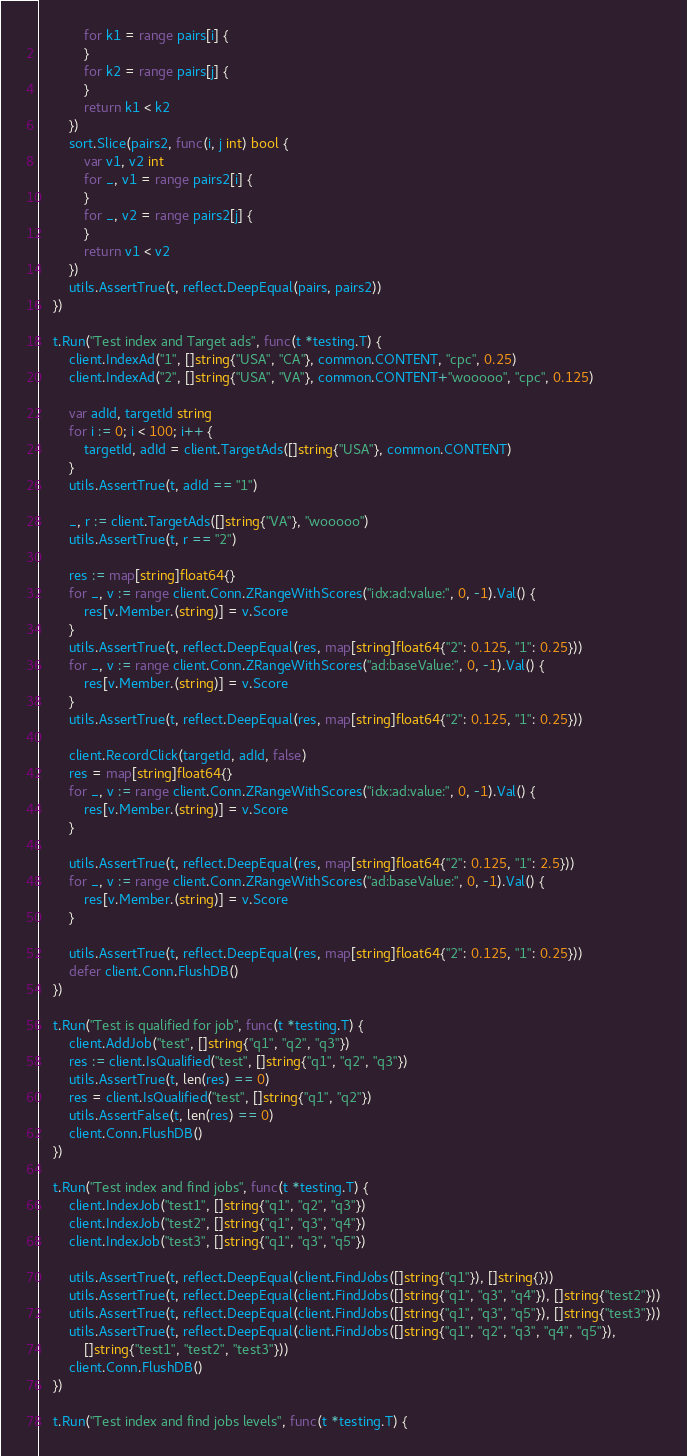Convert code to text. <code><loc_0><loc_0><loc_500><loc_500><_Go_>			for k1 = range pairs[i] {
			}
			for k2 = range pairs[j] {
			}
			return k1 < k2
		})
		sort.Slice(pairs2, func(i, j int) bool {
			var v1, v2 int
			for _, v1 = range pairs2[i] {
			}
			for _, v2 = range pairs2[j] {
			}
			return v1 < v2
		})
		utils.AssertTrue(t, reflect.DeepEqual(pairs, pairs2))
	})

	t.Run("Test index and Target ads", func(t *testing.T) {
		client.IndexAd("1", []string{"USA", "CA"}, common.CONTENT, "cpc", 0.25)
		client.IndexAd("2", []string{"USA", "VA"}, common.CONTENT+"wooooo", "cpc", 0.125)

		var adId, targetId string
		for i := 0; i < 100; i++ {
			targetId, adId = client.TargetAds([]string{"USA"}, common.CONTENT)
		}
		utils.AssertTrue(t, adId == "1")

		_, r := client.TargetAds([]string{"VA"}, "wooooo")
		utils.AssertTrue(t, r == "2")

		res := map[string]float64{}
		for _, v := range client.Conn.ZRangeWithScores("idx:ad:value:", 0, -1).Val() {
			res[v.Member.(string)] = v.Score
		}
		utils.AssertTrue(t, reflect.DeepEqual(res, map[string]float64{"2": 0.125, "1": 0.25}))
		for _, v := range client.Conn.ZRangeWithScores("ad:baseValue:", 0, -1).Val() {
			res[v.Member.(string)] = v.Score
		}
		utils.AssertTrue(t, reflect.DeepEqual(res, map[string]float64{"2": 0.125, "1": 0.25}))

		client.RecordClick(targetId, adId, false)
		res = map[string]float64{}
		for _, v := range client.Conn.ZRangeWithScores("idx:ad:value:", 0, -1).Val() {
			res[v.Member.(string)] = v.Score
		}

		utils.AssertTrue(t, reflect.DeepEqual(res, map[string]float64{"2": 0.125, "1": 2.5}))
		for _, v := range client.Conn.ZRangeWithScores("ad:baseValue:", 0, -1).Val() {
			res[v.Member.(string)] = v.Score
		}

		utils.AssertTrue(t, reflect.DeepEqual(res, map[string]float64{"2": 0.125, "1": 0.25}))
		defer client.Conn.FlushDB()
	})

	t.Run("Test is qualified for job", func(t *testing.T) {
		client.AddJob("test", []string{"q1", "q2", "q3"})
		res := client.IsQualified("test", []string{"q1", "q2", "q3"})
		utils.AssertTrue(t, len(res) == 0)
		res = client.IsQualified("test", []string{"q1", "q2"})
		utils.AssertFalse(t, len(res) == 0)
		client.Conn.FlushDB()
	})

	t.Run("Test index and find jobs", func(t *testing.T) {
		client.IndexJob("test1", []string{"q1", "q2", "q3"})
		client.IndexJob("test2", []string{"q1", "q3", "q4"})
		client.IndexJob("test3", []string{"q1", "q3", "q5"})

		utils.AssertTrue(t, reflect.DeepEqual(client.FindJobs([]string{"q1"}), []string{}))
		utils.AssertTrue(t, reflect.DeepEqual(client.FindJobs([]string{"q1", "q3", "q4"}), []string{"test2"}))
		utils.AssertTrue(t, reflect.DeepEqual(client.FindJobs([]string{"q1", "q3", "q5"}), []string{"test3"}))
		utils.AssertTrue(t, reflect.DeepEqual(client.FindJobs([]string{"q1", "q2", "q3", "q4", "q5"}),
			[]string{"test1", "test2", "test3"}))
		client.Conn.FlushDB()
	})

	t.Run("Test index and find jobs levels", func(t *testing.T) {</code> 